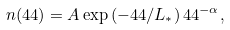Convert formula to latex. <formula><loc_0><loc_0><loc_500><loc_500>n ( \L 4 4 ) = A \exp \left ( - \L 4 4 / L _ { \ast } \right ) \L 4 4 ^ { - \alpha } ,</formula> 